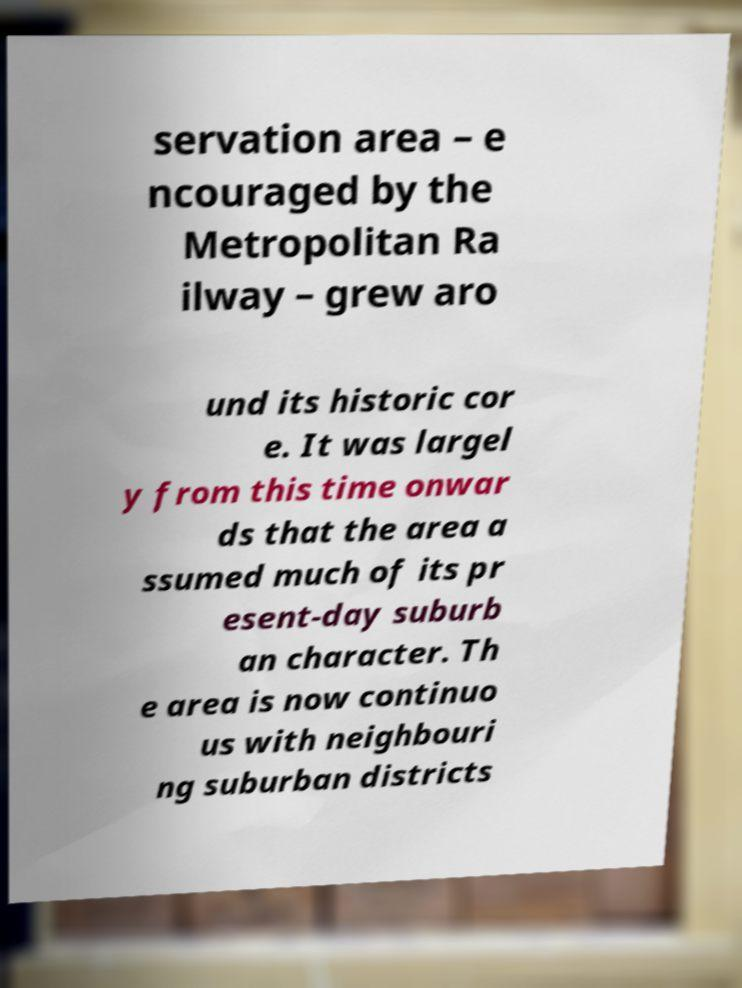Could you assist in decoding the text presented in this image and type it out clearly? servation area – e ncouraged by the Metropolitan Ra ilway – grew aro und its historic cor e. It was largel y from this time onwar ds that the area a ssumed much of its pr esent-day suburb an character. Th e area is now continuo us with neighbouri ng suburban districts 